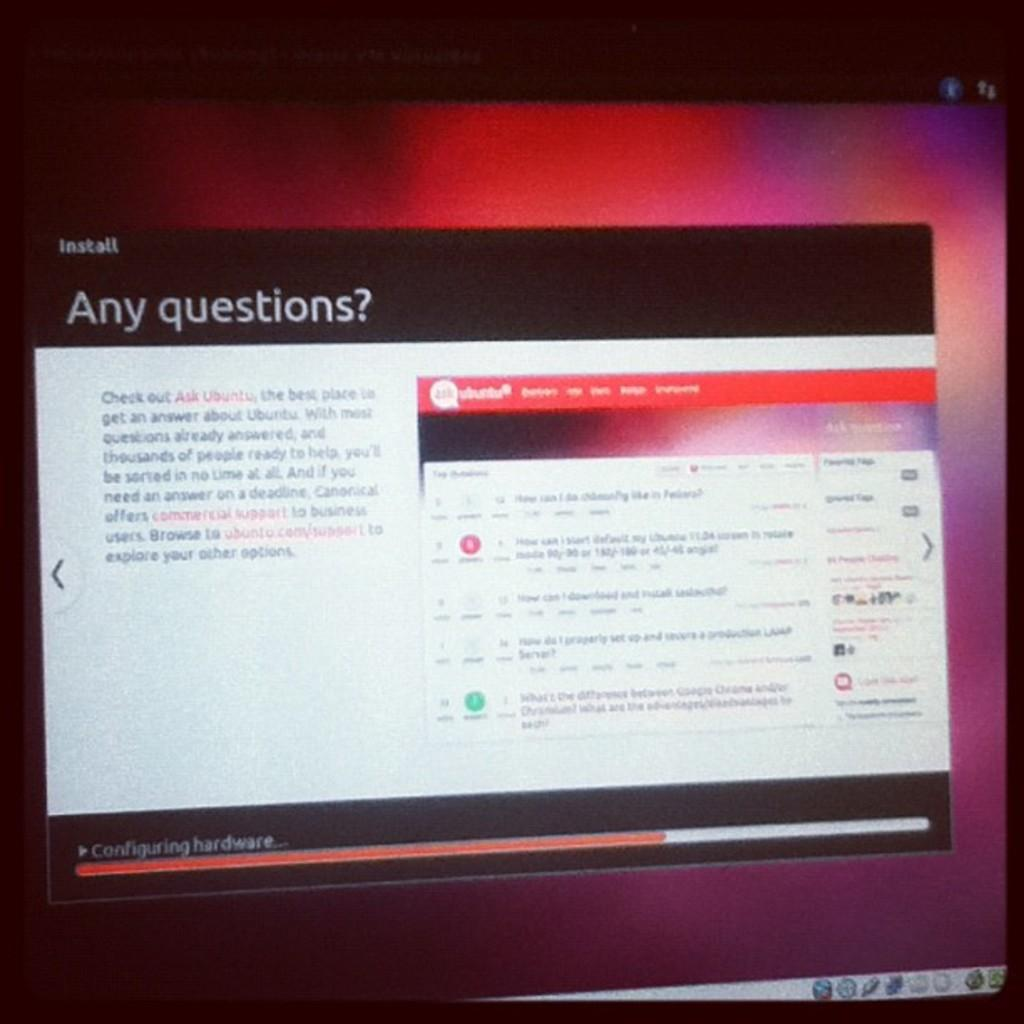<image>
Create a compact narrative representing the image presented. An install page asks if there are any questions. 